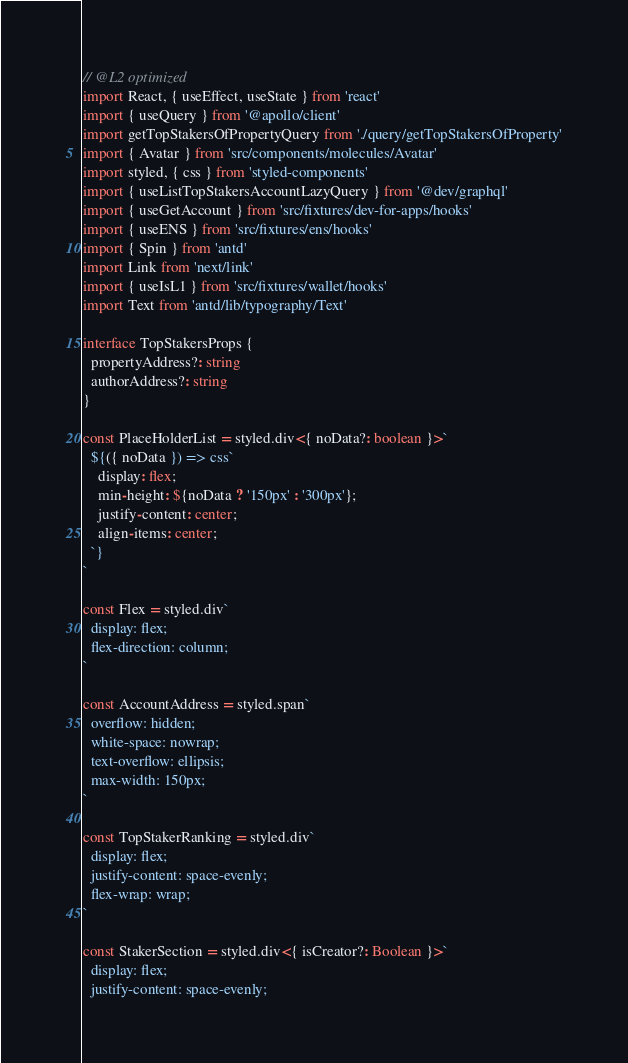<code> <loc_0><loc_0><loc_500><loc_500><_TypeScript_>// @L2 optimized
import React, { useEffect, useState } from 'react'
import { useQuery } from '@apollo/client'
import getTopStakersOfPropertyQuery from './query/getTopStakersOfProperty'
import { Avatar } from 'src/components/molecules/Avatar'
import styled, { css } from 'styled-components'
import { useListTopStakersAccountLazyQuery } from '@dev/graphql'
import { useGetAccount } from 'src/fixtures/dev-for-apps/hooks'
import { useENS } from 'src/fixtures/ens/hooks'
import { Spin } from 'antd'
import Link from 'next/link'
import { useIsL1 } from 'src/fixtures/wallet/hooks'
import Text from 'antd/lib/typography/Text'

interface TopStakersProps {
  propertyAddress?: string
  authorAddress?: string
}

const PlaceHolderList = styled.div<{ noData?: boolean }>`
  ${({ noData }) => css`
    display: flex;
    min-height: ${noData ? '150px' : '300px'};
    justify-content: center;
    align-items: center;
  `}
`

const Flex = styled.div`
  display: flex;
  flex-direction: column;
`

const AccountAddress = styled.span`
  overflow: hidden;
  white-space: nowrap;
  text-overflow: ellipsis;
  max-width: 150px;
`

const TopStakerRanking = styled.div`
  display: flex;
  justify-content: space-evenly;
  flex-wrap: wrap;
`

const StakerSection = styled.div<{ isCreator?: Boolean }>`
  display: flex;
  justify-content: space-evenly;</code> 